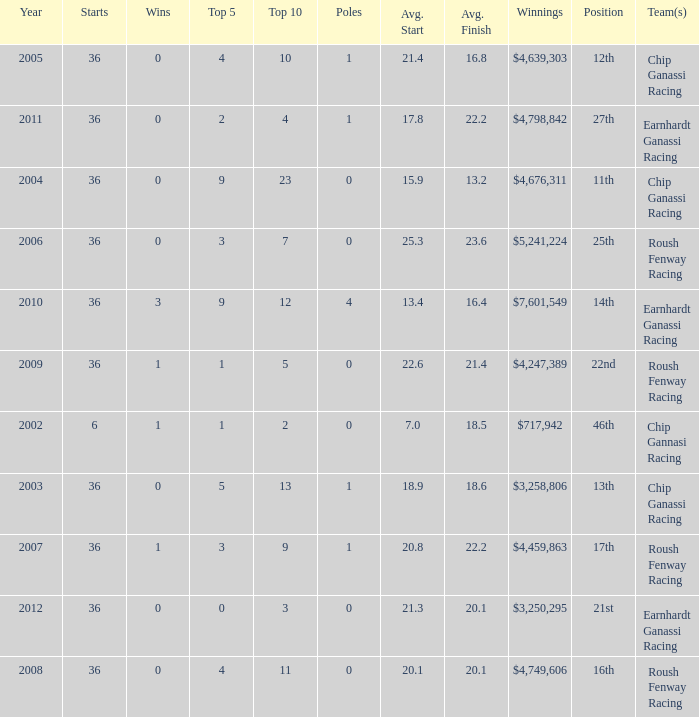Name the starts when position is 16th 36.0. 